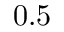<formula> <loc_0><loc_0><loc_500><loc_500>0 . 5</formula> 